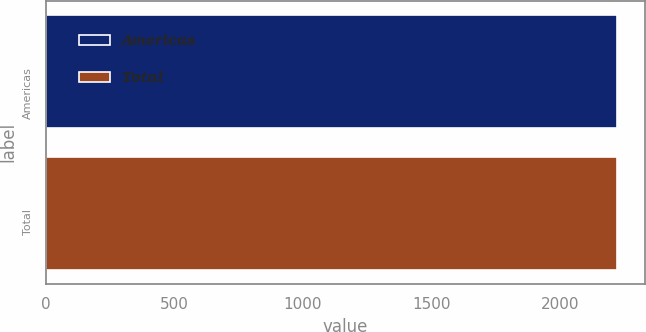<chart> <loc_0><loc_0><loc_500><loc_500><bar_chart><fcel>Americas<fcel>Total<nl><fcel>2219<fcel>2219.1<nl></chart> 